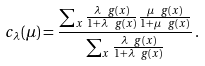Convert formula to latex. <formula><loc_0><loc_0><loc_500><loc_500>c _ { \lambda } ( \mu ) = \frac { \sum _ { x } \frac { \lambda \ g ( x ) } { 1 + \lambda \ g ( x ) } \frac { \mu \ g ( x ) } { 1 + \mu \ g ( x ) } } { \sum _ { x } \frac { \lambda \ g ( x ) } { 1 + \lambda \ g ( x ) } } \, .</formula> 